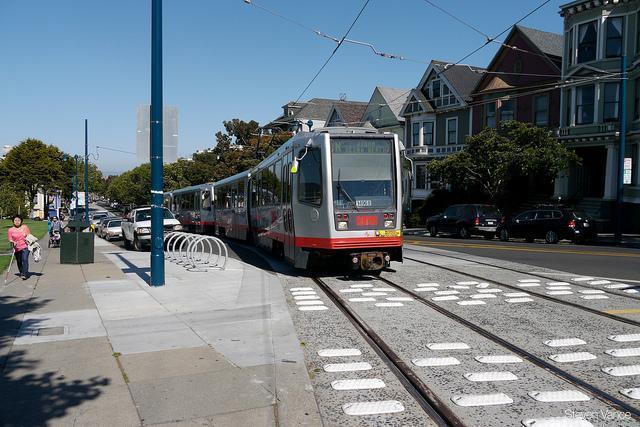How many cars are there?
Give a very brief answer. 2. 